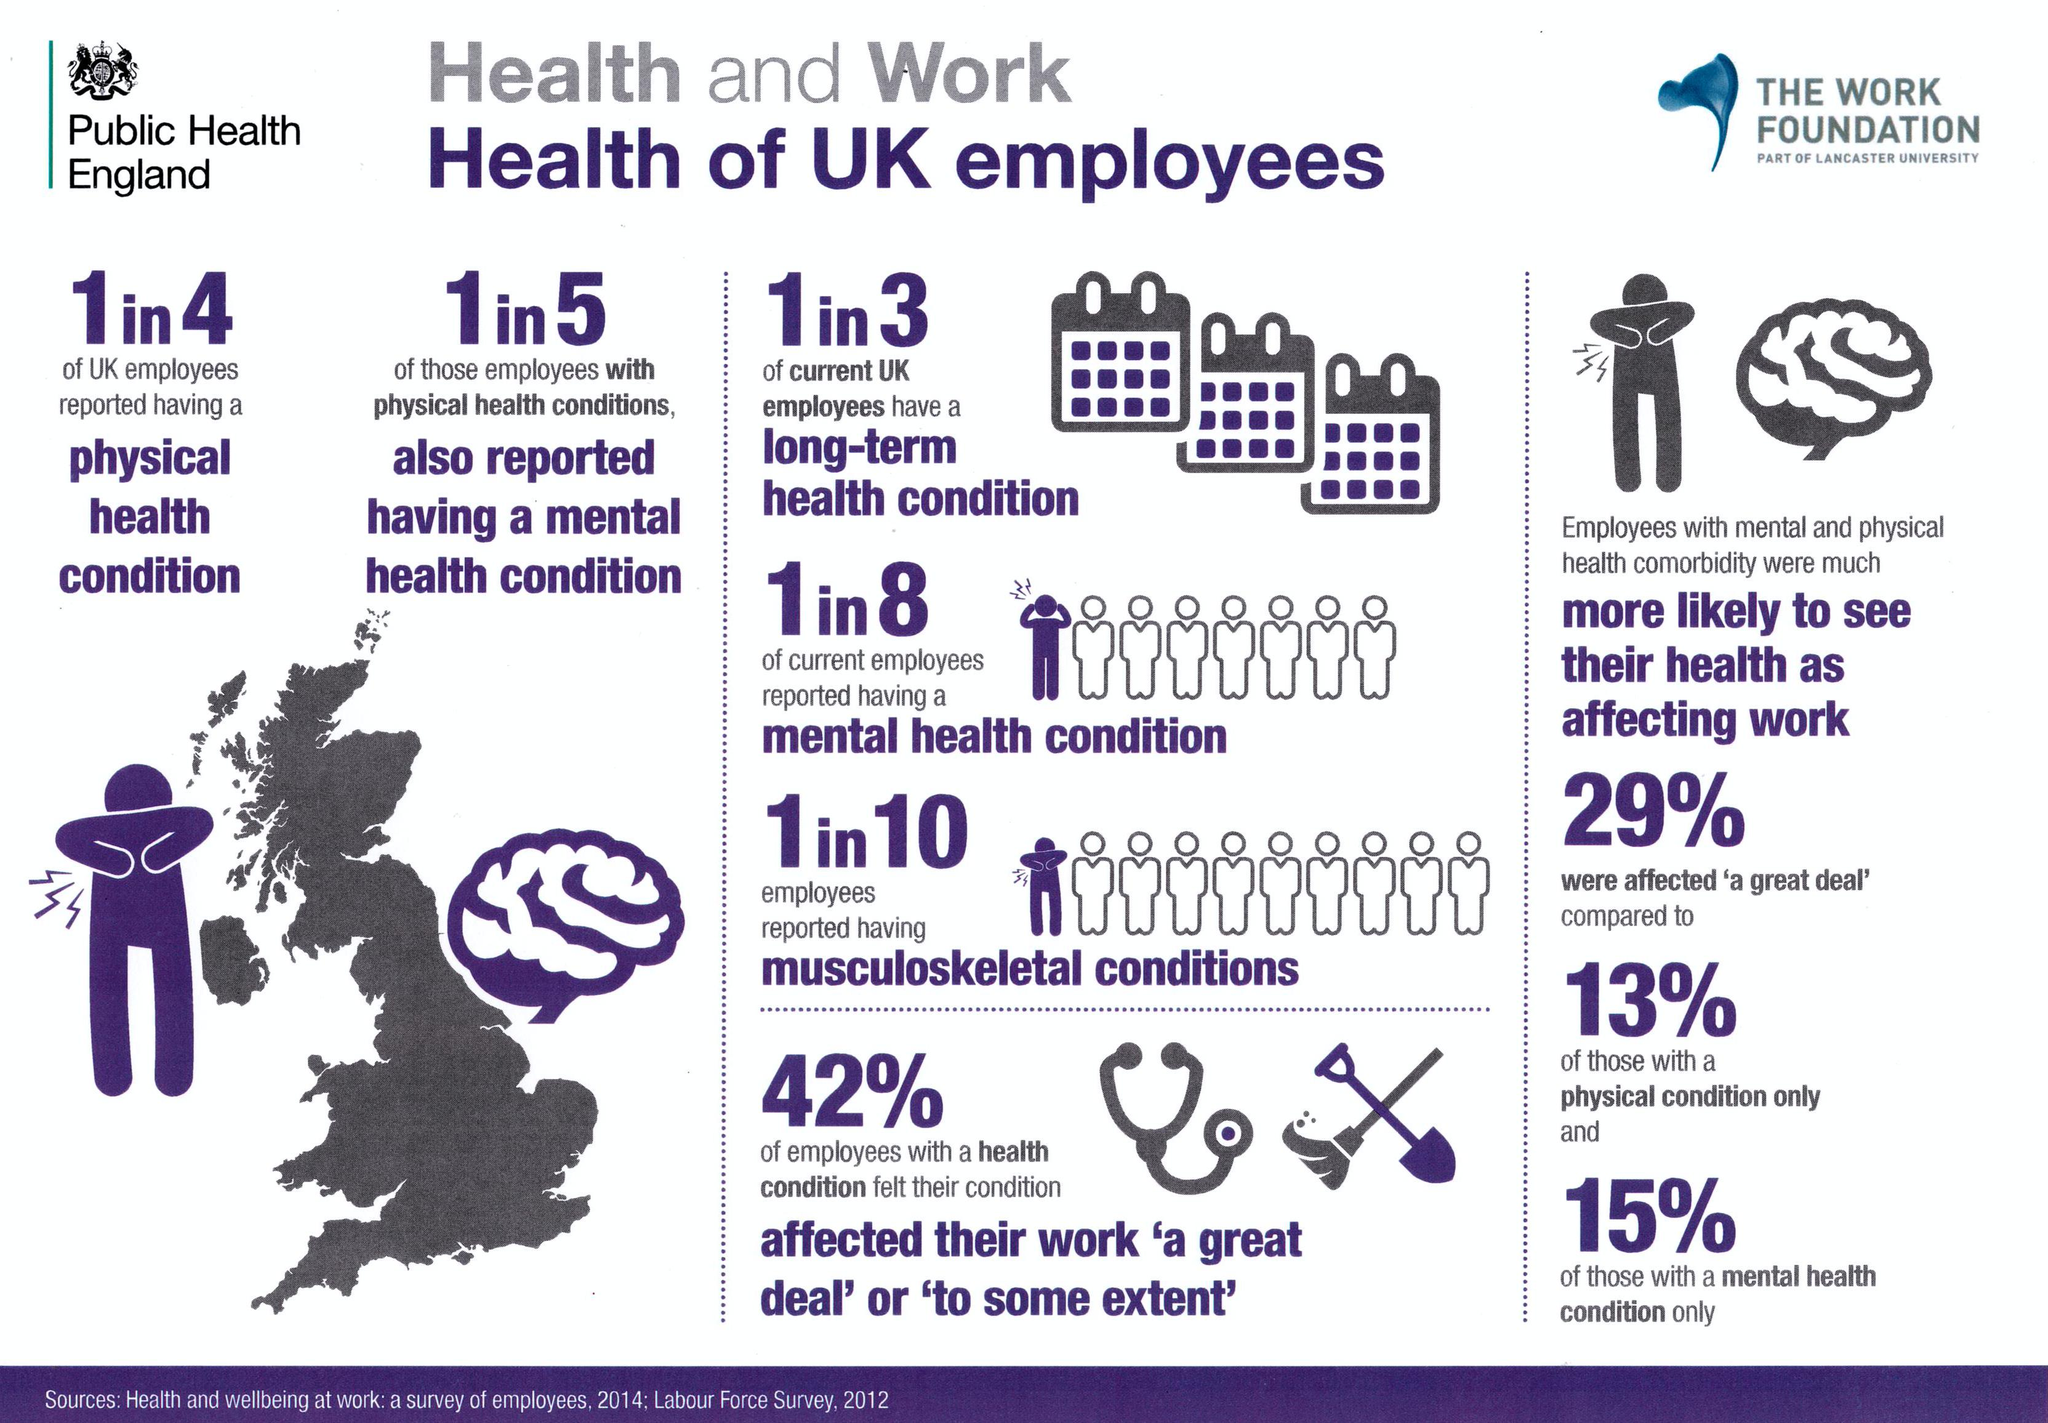Highlight a few significant elements in this photo. According to a survey, 58% of employees in the UK are not significantly affected by their health conditions in their work. According to a survey, only 15% of employees in the UK are affected by their mental health condition at work. 